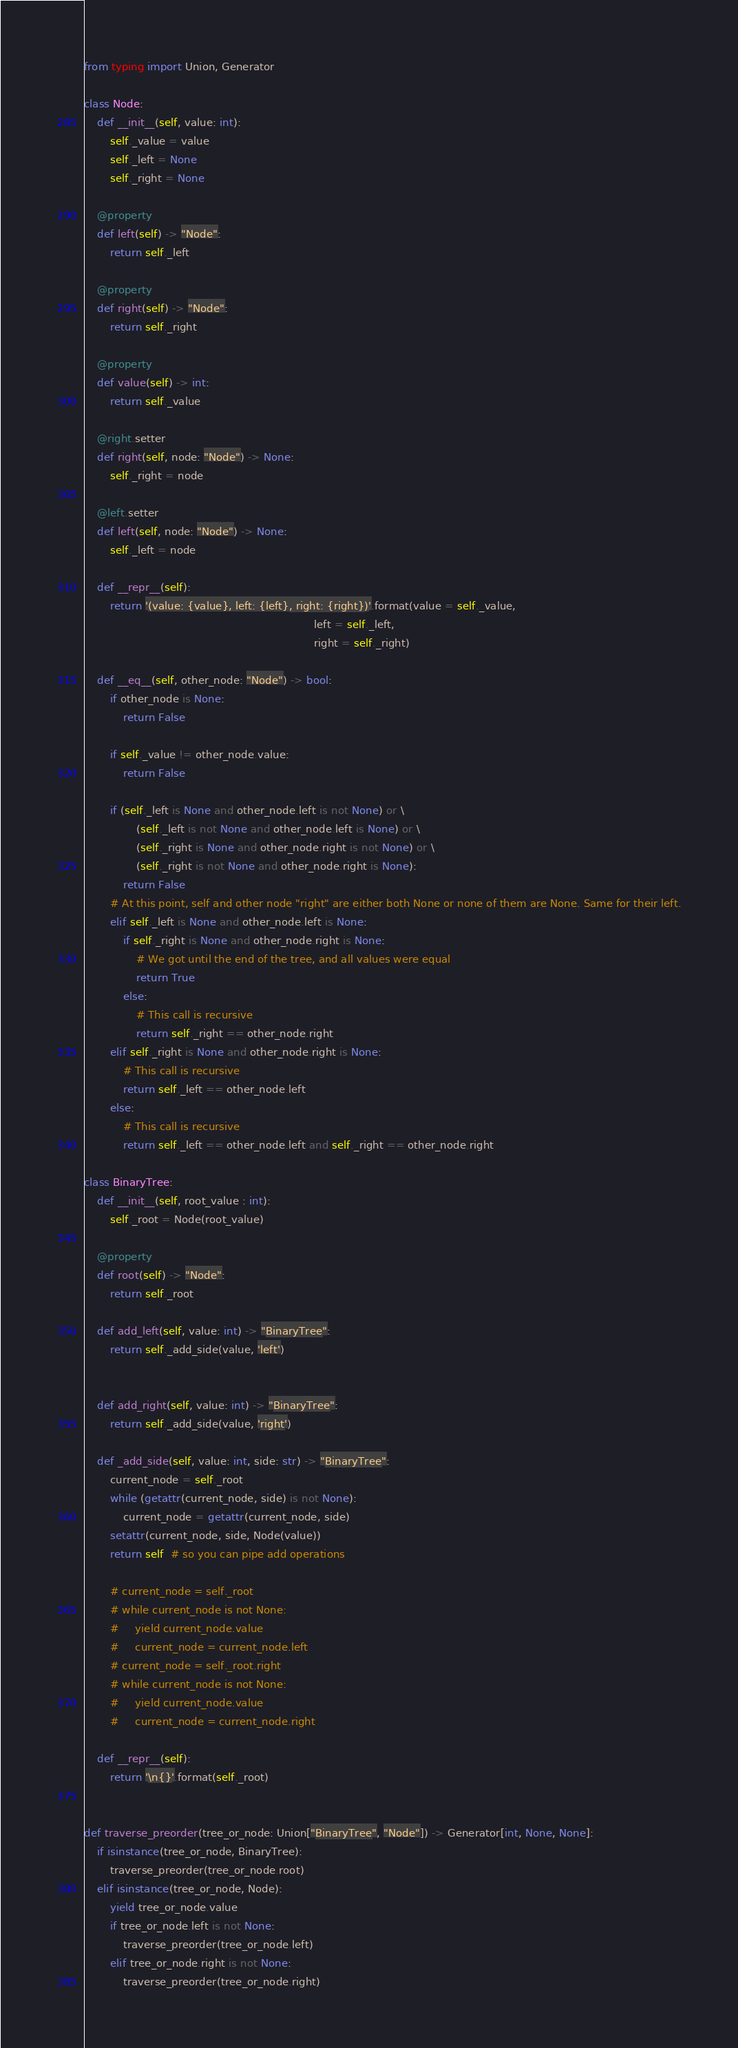<code> <loc_0><loc_0><loc_500><loc_500><_Python_>from typing import Union, Generator

class Node:
    def __init__(self, value: int):
        self._value = value
        self._left = None
        self._right = None

    @property
    def left(self) -> "Node":
        return self._left

    @property
    def right(self) -> "Node":
        return self._right

    @property
    def value(self) -> int:
        return self._value

    @right.setter
    def right(self, node: "Node") -> None:
        self._right = node

    @left.setter
    def left(self, node: "Node") -> None:
        self._left = node

    def __repr__(self):
        return '(value: {value}, left: {left}, right: {right})'.format(value = self._value,
                                                                      left = self._left,
                                                                      right = self._right)

    def __eq__(self, other_node: "Node") -> bool:
        if other_node is None:
            return False

        if self._value != other_node.value:
            return False

        if (self._left is None and other_node.left is not None) or \
                (self._left is not None and other_node.left is None) or \
                (self._right is None and other_node.right is not None) or \
                (self._right is not None and other_node.right is None):
            return False
        # At this point, self and other node "right" are either both None or none of them are None. Same for their left.
        elif self._left is None and other_node.left is None:
            if self._right is None and other_node.right is None:
                # We got until the end of the tree, and all values were equal
                return True
            else:
                # This call is recursive
                return self._right == other_node.right
        elif self._right is None and other_node.right is None:
            # This call is recursive
            return self._left == other_node.left
        else:
            # This call is recursive
            return self._left == other_node.left and self._right == other_node.right

class BinaryTree:
    def __init__(self, root_value : int):
        self._root = Node(root_value)

    @property
    def root(self) -> "Node":
        return self._root

    def add_left(self, value: int) -> "BinaryTree":
        return self._add_side(value, 'left')


    def add_right(self, value: int) -> "BinaryTree":
        return self._add_side(value, 'right')

    def _add_side(self, value: int, side: str) -> "BinaryTree":
        current_node = self._root
        while (getattr(current_node, side) is not None):
            current_node = getattr(current_node, side)
        setattr(current_node, side, Node(value))
        return self  # so you can pipe add operations

        # current_node = self._root
        # while current_node is not None:
        #     yield current_node.value
        #     current_node = current_node.left
        # current_node = self._root.right
        # while current_node is not None:
        #     yield current_node.value
        #     current_node = current_node.right

    def __repr__(self):
        return '\n{}'.format(self._root)


def traverse_preorder(tree_or_node: Union["BinaryTree", "Node"]) -> Generator[int, None, None]:
    if isinstance(tree_or_node, BinaryTree):
        traverse_preorder(tree_or_node.root)
    elif isinstance(tree_or_node, Node):
        yield tree_or_node.value
        if tree_or_node.left is not None:
            traverse_preorder(tree_or_node.left)
        elif tree_or_node.right is not None:
            traverse_preorder(tree_or_node.right)</code> 